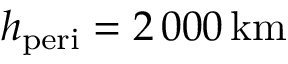Convert formula to latex. <formula><loc_0><loc_0><loc_500><loc_500>h _ { p e r i } = 2 \, 0 0 0 \, k m</formula> 